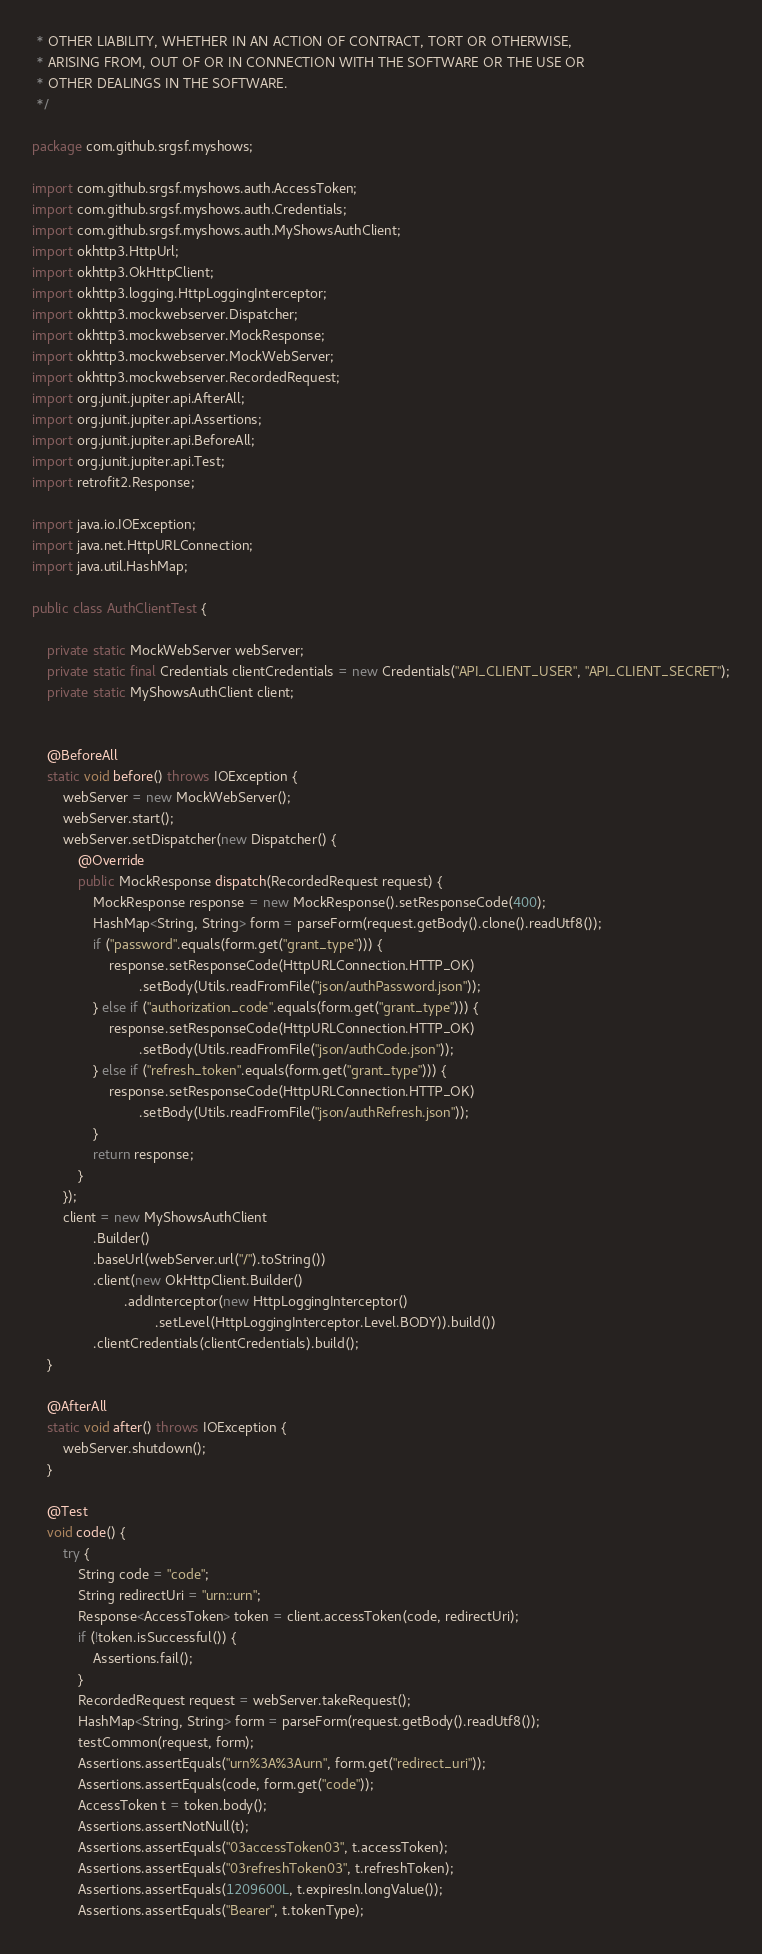Convert code to text. <code><loc_0><loc_0><loc_500><loc_500><_Java_> * OTHER LIABILITY, WHETHER IN AN ACTION OF CONTRACT, TORT OR OTHERWISE,
 * ARISING FROM, OUT OF OR IN CONNECTION WITH THE SOFTWARE OR THE USE OR
 * OTHER DEALINGS IN THE SOFTWARE.
 */

package com.github.srgsf.myshows;

import com.github.srgsf.myshows.auth.AccessToken;
import com.github.srgsf.myshows.auth.Credentials;
import com.github.srgsf.myshows.auth.MyShowsAuthClient;
import okhttp3.HttpUrl;
import okhttp3.OkHttpClient;
import okhttp3.logging.HttpLoggingInterceptor;
import okhttp3.mockwebserver.Dispatcher;
import okhttp3.mockwebserver.MockResponse;
import okhttp3.mockwebserver.MockWebServer;
import okhttp3.mockwebserver.RecordedRequest;
import org.junit.jupiter.api.AfterAll;
import org.junit.jupiter.api.Assertions;
import org.junit.jupiter.api.BeforeAll;
import org.junit.jupiter.api.Test;
import retrofit2.Response;

import java.io.IOException;
import java.net.HttpURLConnection;
import java.util.HashMap;

public class AuthClientTest {

    private static MockWebServer webServer;
    private static final Credentials clientCredentials = new Credentials("API_CLIENT_USER", "API_CLIENT_SECRET");
    private static MyShowsAuthClient client;


    @BeforeAll
    static void before() throws IOException {
        webServer = new MockWebServer();
        webServer.start();
        webServer.setDispatcher(new Dispatcher() {
            @Override
            public MockResponse dispatch(RecordedRequest request) {
                MockResponse response = new MockResponse().setResponseCode(400);
                HashMap<String, String> form = parseForm(request.getBody().clone().readUtf8());
                if ("password".equals(form.get("grant_type"))) {
                    response.setResponseCode(HttpURLConnection.HTTP_OK)
                            .setBody(Utils.readFromFile("json/authPassword.json"));
                } else if ("authorization_code".equals(form.get("grant_type"))) {
                    response.setResponseCode(HttpURLConnection.HTTP_OK)
                            .setBody(Utils.readFromFile("json/authCode.json"));
                } else if ("refresh_token".equals(form.get("grant_type"))) {
                    response.setResponseCode(HttpURLConnection.HTTP_OK)
                            .setBody(Utils.readFromFile("json/authRefresh.json"));
                }
                return response;
            }
        });
        client = new MyShowsAuthClient
                .Builder()
                .baseUrl(webServer.url("/").toString())
                .client(new OkHttpClient.Builder()
                        .addInterceptor(new HttpLoggingInterceptor()
                                .setLevel(HttpLoggingInterceptor.Level.BODY)).build())
                .clientCredentials(clientCredentials).build();
    }

    @AfterAll
    static void after() throws IOException {
        webServer.shutdown();
    }

    @Test
    void code() {
        try {
            String code = "code";
            String redirectUri = "urn::urn";
            Response<AccessToken> token = client.accessToken(code, redirectUri);
            if (!token.isSuccessful()) {
                Assertions.fail();
            }
            RecordedRequest request = webServer.takeRequest();
            HashMap<String, String> form = parseForm(request.getBody().readUtf8());
            testCommon(request, form);
            Assertions.assertEquals("urn%3A%3Aurn", form.get("redirect_uri"));
            Assertions.assertEquals(code, form.get("code"));
            AccessToken t = token.body();
            Assertions.assertNotNull(t);
            Assertions.assertEquals("03accessToken03", t.accessToken);
            Assertions.assertEquals("03refreshToken03", t.refreshToken);
            Assertions.assertEquals(1209600L, t.expiresIn.longValue());
            Assertions.assertEquals("Bearer", t.tokenType);</code> 